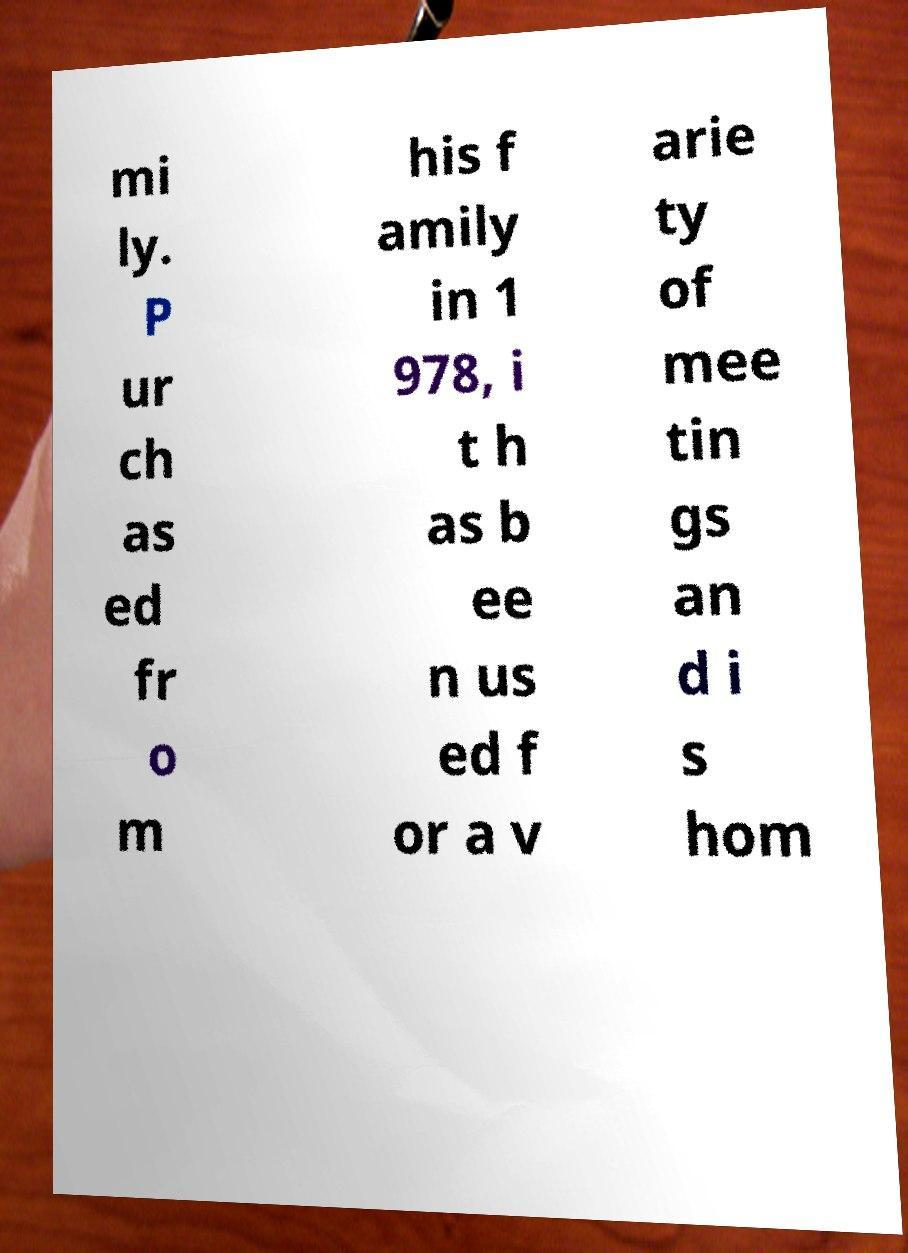I need the written content from this picture converted into text. Can you do that? mi ly. P ur ch as ed fr o m his f amily in 1 978, i t h as b ee n us ed f or a v arie ty of mee tin gs an d i s hom 